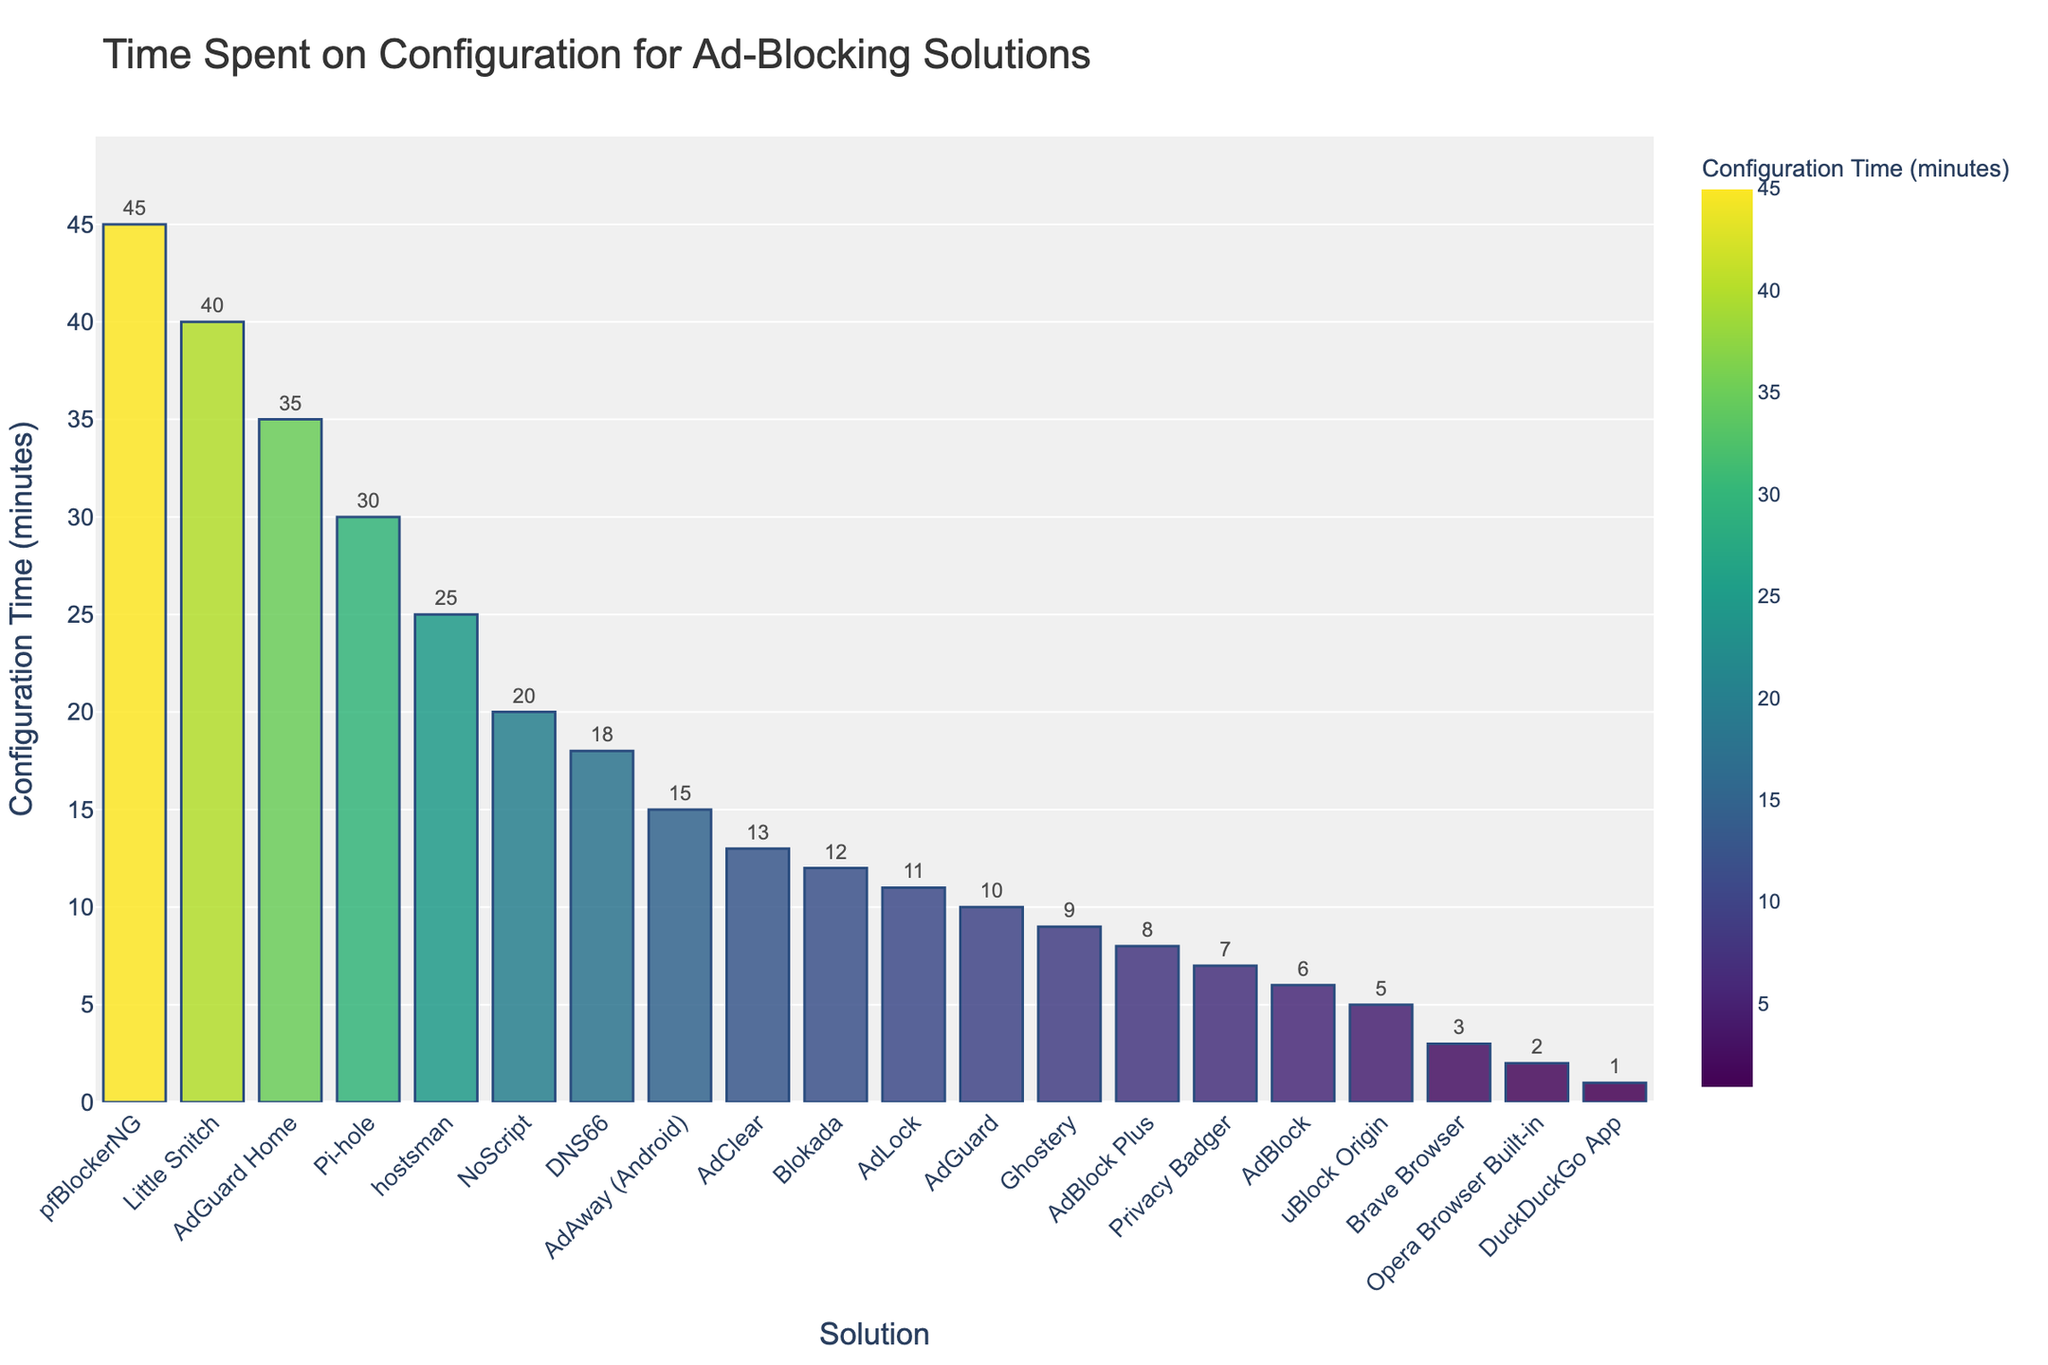Which ad-blocking solution requires the least time for configuration? From the figure, the bar representing "DuckDuckGo App" is the shortest and positioned at the far right, indicating it has the lowest configuration time of 1 minute.
Answer: DuckDuckGo App Which ad-blocking solution has the highest configuration time? The tallest bar on the left side of the chart represents "pfBlockerNG," which indicates it requires the most time for configuration at 45 minutes.
Answer: pfBlockerNG What is the difference in configuration time between Pi-hole and AdAway (Android)? Locate the bars for Pi-hole and AdAway (Android). Pi-hole has a configuration time of 30 minutes, and AdAway (Android) has 15 minutes. Subtracting 15 from 30 gives the difference.
Answer: 15 minutes What is the average configuration time for AdBlock Plus, Ghostery, and NoScript? Identify the individual configuration times for AdBlock Plus (8 minutes), Ghostery (9 minutes), and NoScript (20 minutes). Use the formula (8 + 9 + 20) / 3 to get the average.
Answer: 12.33 minutes How many solutions require more than 20 minutes for configuration? From the chart, identify and count the bars whose height surpasses 20 minutes: AdGuard Home, hostsman, Little Snitch, pfBlockerNG.
Answer: 4 solutions Which solutions have configuration times between 5 minutes and 15 minutes? From the chart, identify bars corresponding to this range. They include uBlock Origin, AdBlock Plus, Privacy Badger, Blokada, Ghostery, AdAway (Android), AdBlock, and AdLock.
Answer: 8 solutions Is the configuration time for Brave Browser greater than or less than for Opera Browser Built-in? Compare the height of the bars for Brave Browser and Opera Browser Built-in. Brave Browser is taller (3 minutes) than Opera Browser Built-in (2 minutes).
Answer: Greater What is the sum of the configuration times for the solutions uBlock Origin, AdGuard, and DNS66? Locate the configuration times for uBlock Origin (5 minutes), AdGuard (10 minutes), and DNS66 (18 minutes). Add these values: 5 + 10 + 18.
Answer: 33 minutes How does the color intensity change as configuration time increases? In the chart, the color of the bars is mapped to the configuration time, with higher times having darker colors. Visually, as the configuration time increases, the color of the bars transitions to a darker shade.
Answer: Darker Which ad-blocking solutions take exactly twice the configuration time of DuckDuckGo App? DuckDuckGo App requires 1 minute for configuration. Look for solutions taking 2 minutes; only the Opera Browser Built-in has 2 minutes.
Answer: Opera Browser Built-in 